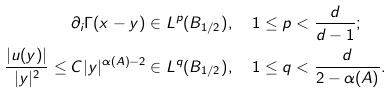Convert formula to latex. <formula><loc_0><loc_0><loc_500><loc_500>\partial _ { i } \Gamma ( x - y ) \in L ^ { p } ( B _ { 1 / 2 } ) & , \quad 1 \leq p < \frac { d } { d - 1 } ; \\ \frac { | u ( y ) | } { | y | ^ { 2 } } \leq C | y | ^ { \alpha ( A ) - 2 } \in L ^ { q } ( B _ { 1 / 2 } ) & , \quad 1 \leq q < \frac { d } { 2 - \alpha ( A ) } .</formula> 